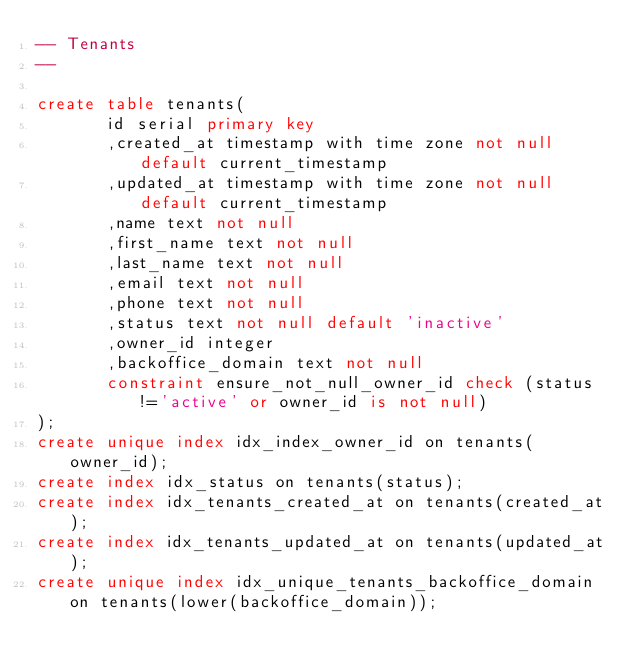Convert code to text. <code><loc_0><loc_0><loc_500><loc_500><_SQL_>-- Tenants
--

create table tenants(
       id serial primary key
       ,created_at timestamp with time zone not null default current_timestamp
       ,updated_at timestamp with time zone not null default current_timestamp
       ,name text not null
       ,first_name text not null
       ,last_name text not null
       ,email text not null
       ,phone text not null
       ,status text not null default 'inactive'
       ,owner_id integer
       ,backoffice_domain text not null
       constraint ensure_not_null_owner_id check (status!='active' or owner_id is not null)
);
create unique index idx_index_owner_id on tenants(owner_id);
create index idx_status on tenants(status);
create index idx_tenants_created_at on tenants(created_at);
create index idx_tenants_updated_at on tenants(updated_at);
create unique index idx_unique_tenants_backoffice_domain on tenants(lower(backoffice_domain));
</code> 